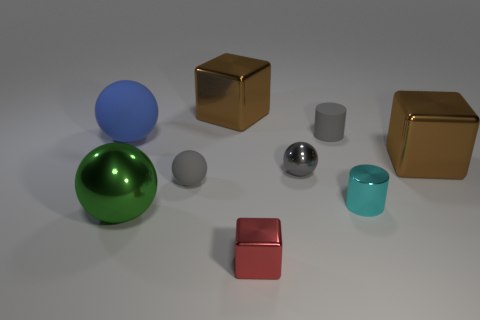Are there fewer cyan cylinders to the left of the small red block than large brown blocks on the left side of the small shiny cylinder? Upon examining the image, it appears that to the left of the small red block, there is only one cyan cylinder. Comparatively, on the left side of the small shiny cylinder, there are two large brown blocks. Therefore, the answer is yes, there are fewer cyan cylinders to the left of the small red block than large brown blocks on the left side of the small shiny cylinder. 